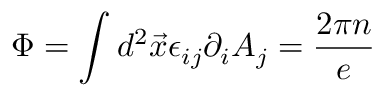Convert formula to latex. <formula><loc_0><loc_0><loc_500><loc_500>\Phi = \int d ^ { 2 } \vec { x } \epsilon _ { i j } \partial _ { i } A _ { j } = \frac { 2 \pi n } { e }</formula> 